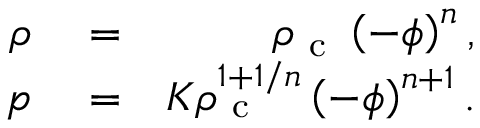Convert formula to latex. <formula><loc_0><loc_0><loc_500><loc_500>\begin{array} { r l r } { \rho } & = } & { \rho _ { c } \left ( - \phi \right ) ^ { n } , } \\ { p } & = } & { K \rho _ { c } ^ { 1 + 1 / n } \left ( - \phi \right ) ^ { n + 1 } . } \end{array}</formula> 